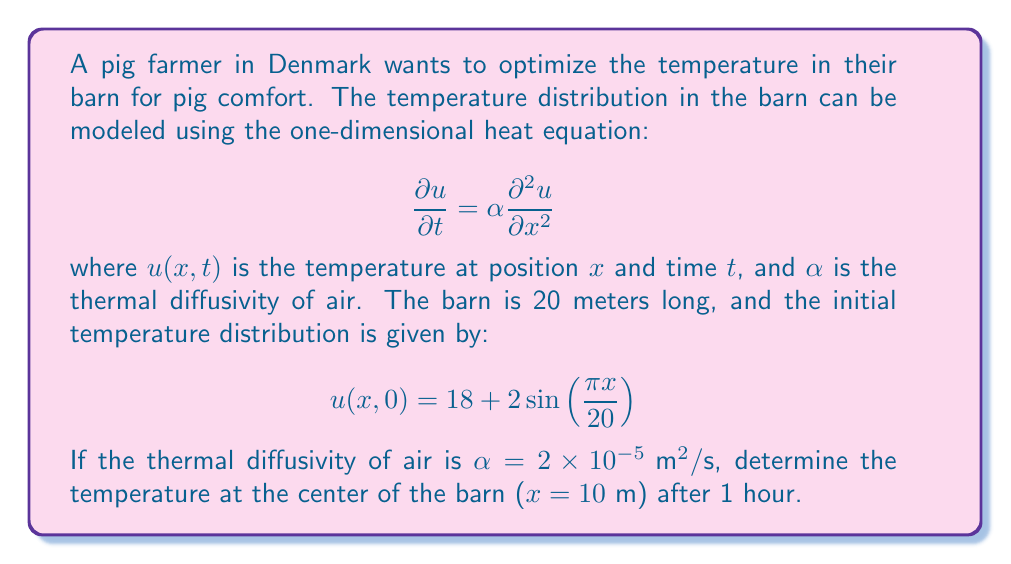Teach me how to tackle this problem. To solve this problem, we'll use the separation of variables method for the heat equation.

1) The general solution to the heat equation with the given boundary conditions is:

   $$u(x,t) = 18 + \sum_{n=1}^{\infty} B_n \sin(\frac{n\pi x}{L})e^{-\alpha(\frac{n\pi}{L})^2t}$$

   where $L = 20$ m is the length of the barn.

2) From the initial condition, we can see that only the first term ($n=1$) of the series is present:

   $$u(x,0) = 18 + 2\sin(\frac{\pi x}{20})$$

3) Therefore, $B_1 = 2$ and $B_n = 0$ for $n > 1$. Our solution simplifies to:

   $$u(x,t) = 18 + 2\sin(\frac{\pi x}{20})e^{-\alpha(\frac{\pi}{20})^2t}$$

4) Now, we need to calculate the temperature at $x = 10$ m and $t = 3600$ s (1 hour):

   $$u(10,3600) = 18 + 2\sin(\frac{\pi \cdot 10}{20})e^{-2\times10^{-5}(\frac{\pi}{20})^2 \cdot 3600}$$

5) Simplify:
   - $\sin(\frac{\pi \cdot 10}{20}) = \sin(\frac{\pi}{2}) = 1$
   - $e^{-2\times10^{-5}(\frac{\pi}{20})^2 \cdot 3600} \approx 0.9291$

6) Therefore:

   $$u(10,3600) = 18 + 2 \cdot 1 \cdot 0.9291 = 19.8582$$

The temperature at the center of the barn after 1 hour will be approximately 19.86°C.
Answer: 19.86°C 